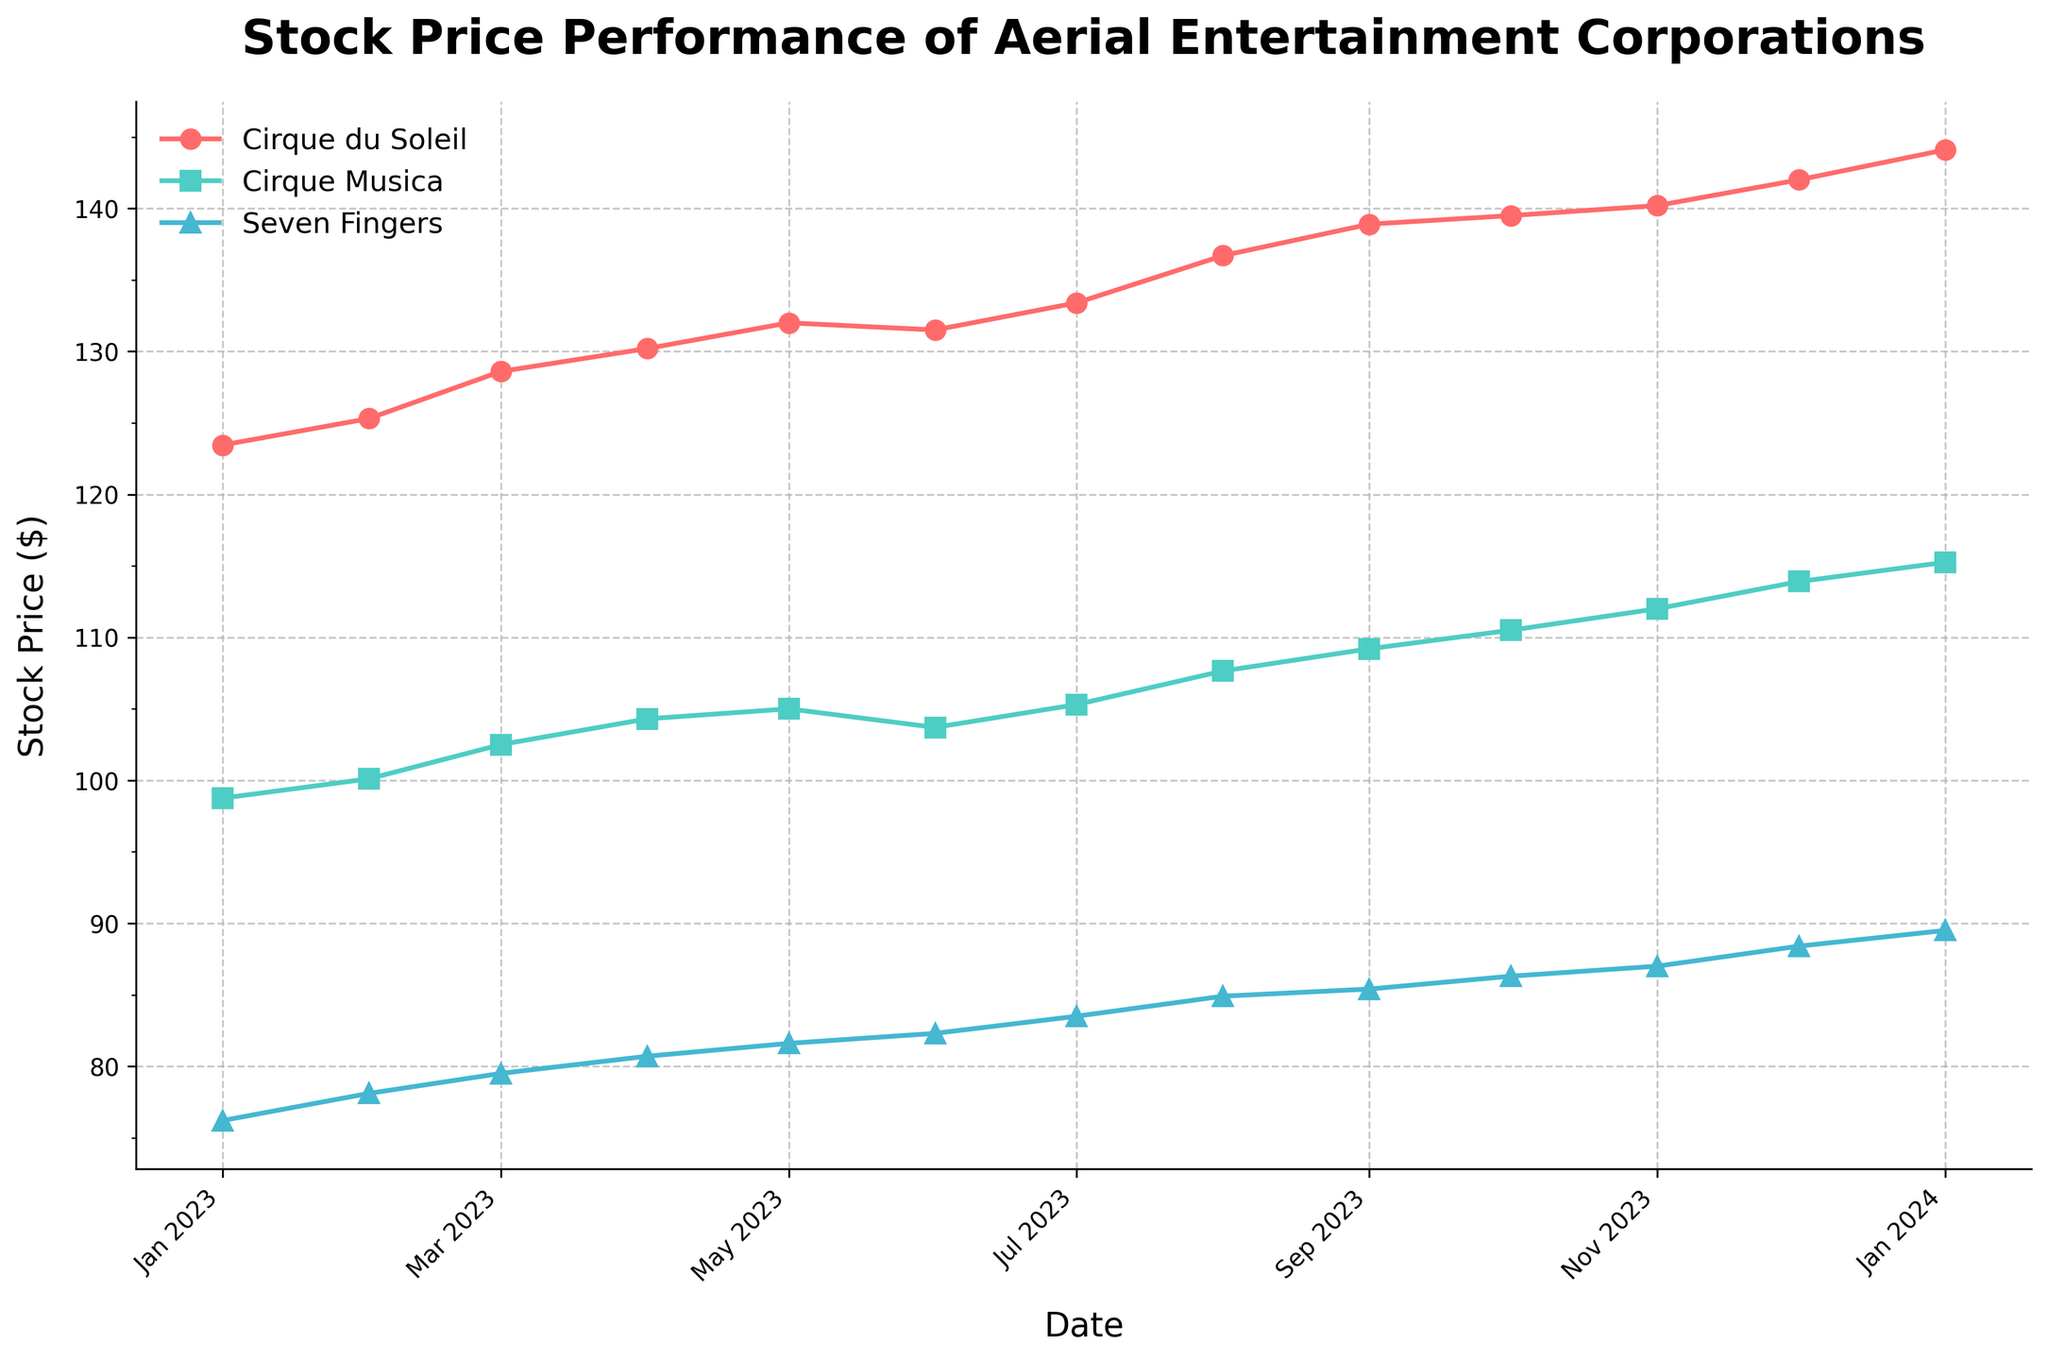What is the title of the figure? The title of the figure is usually prominently displayed at the top. In this case, the title is "Stock Price Performance of Aerial Entertainment Corporations".
Answer: Stock Price Performance of Aerial Entertainment Corporations What are the start and end dates for the data displayed in the plot? The x-axis shows the date range for the data. The data starts from January 1, 2023, and ends on January 1, 2024.
Answer: January 1, 2023 to January 1, 2024 Which company had the highest stock price on January 1, 2024? To answer this, look at the data points for January 1, 2024, for each company. Cirque du Soleil had the highest stock price at $144.10 on that date.
Answer: Cirque du Soleil By how much did the stock price of Cirque Musica increase from January 1, 2023, to January 1, 2024? Find the stock prices for Cirque Musica on January 1, 2023, and January 1, 2024, and compute the difference. The stock price increased from $98.75 to $115.25, so the difference is $115.25 - $98.75 = $16.50.
Answer: $16.50 Which company shows the most consistent upward trend in stock price throughout the year? Visually inspect the lines to see which one shows a steady rise without significant dips. Cirque du Soleil shows a consistent upward trend throughout the year.
Answer: Cirque du Soleil What is the difference in stock price between Cirque du Soleil and Seven Fingers on July 1, 2023? Look at the stock prices for both companies on July 1, 2023. For Cirque du Soleil, it is $133.40, and for Seven Fingers, it is $83.50. The difference is $133.40 - $83.50 = $49.90.
Answer: $49.90 Which company had the lowest stock price at any point during the year? Look at the lowest points on each line. The lowest stock price is for Seven Fingers on January 1, 2023, at $76.20.
Answer: Seven Fingers How does Cirque Musica's stock price on October 1, 2023, compare to its stock price on April 1, 2023? Find the stock prices on those dates for Cirque Musica. On April 1, 2023, it was $104.30, and on October 1, 2023, it was $110.50. The stock price increased by $110.50 - $104.30 = $6.20.
Answer: Increase by $6.20 Which company had the highest increase in stock price from January 1, 2023, to December 1, 2023? Calculate the increase for each company by subtracting the January 1, 2023, stock price from the December 1, 2023, stock price. Cirque du Soleil's increase: $142.00 - $123.45 = $18.55, Cirque Musica's increase: $113.90 - $98.75 = $15.15, Seven Fingers' increase: $88.40 - $76.20 = $12.20. Cirque du Soleil had the highest increase of $18.55.
Answer: Cirque du Soleil 